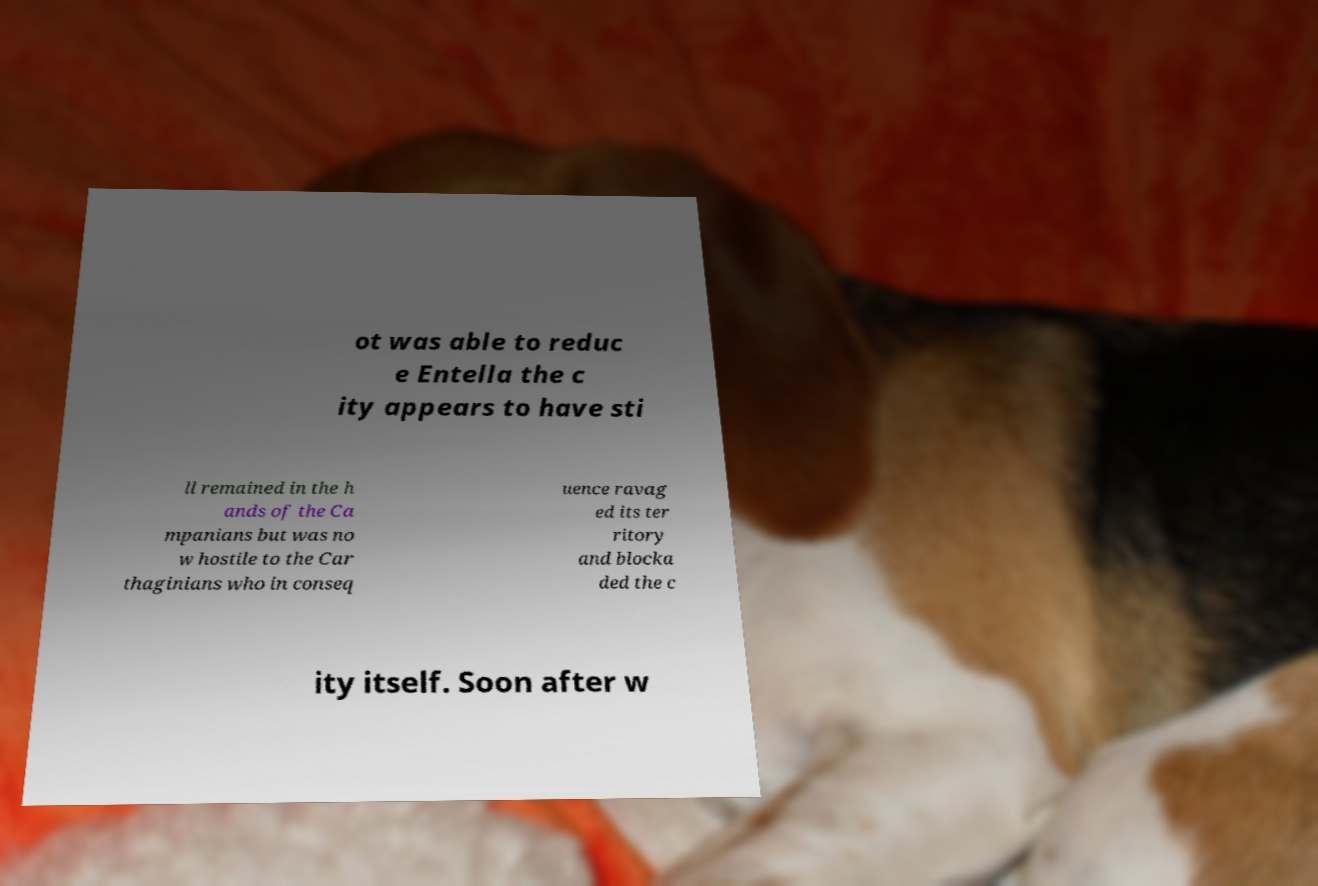There's text embedded in this image that I need extracted. Can you transcribe it verbatim? ot was able to reduc e Entella the c ity appears to have sti ll remained in the h ands of the Ca mpanians but was no w hostile to the Car thaginians who in conseq uence ravag ed its ter ritory and blocka ded the c ity itself. Soon after w 